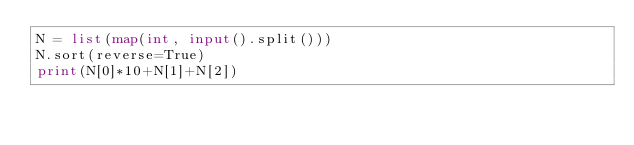Convert code to text. <code><loc_0><loc_0><loc_500><loc_500><_Python_>N = list(map(int, input().split()))
N.sort(reverse=True)
print(N[0]*10+N[1]+N[2])</code> 